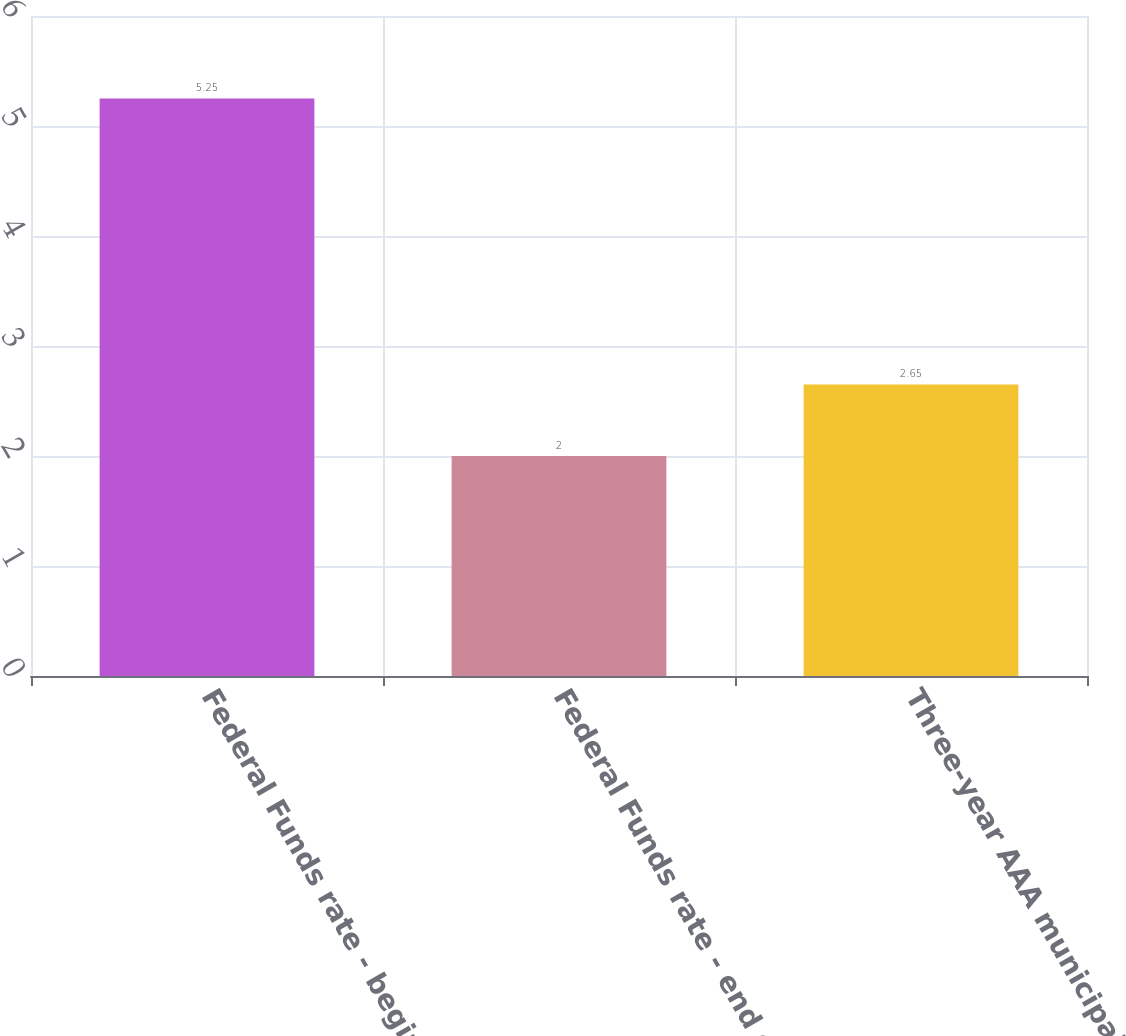Convert chart to OTSL. <chart><loc_0><loc_0><loc_500><loc_500><bar_chart><fcel>Federal Funds rate - beginning<fcel>Federal Funds rate - end of<fcel>Three-year AAA municipal<nl><fcel>5.25<fcel>2<fcel>2.65<nl></chart> 